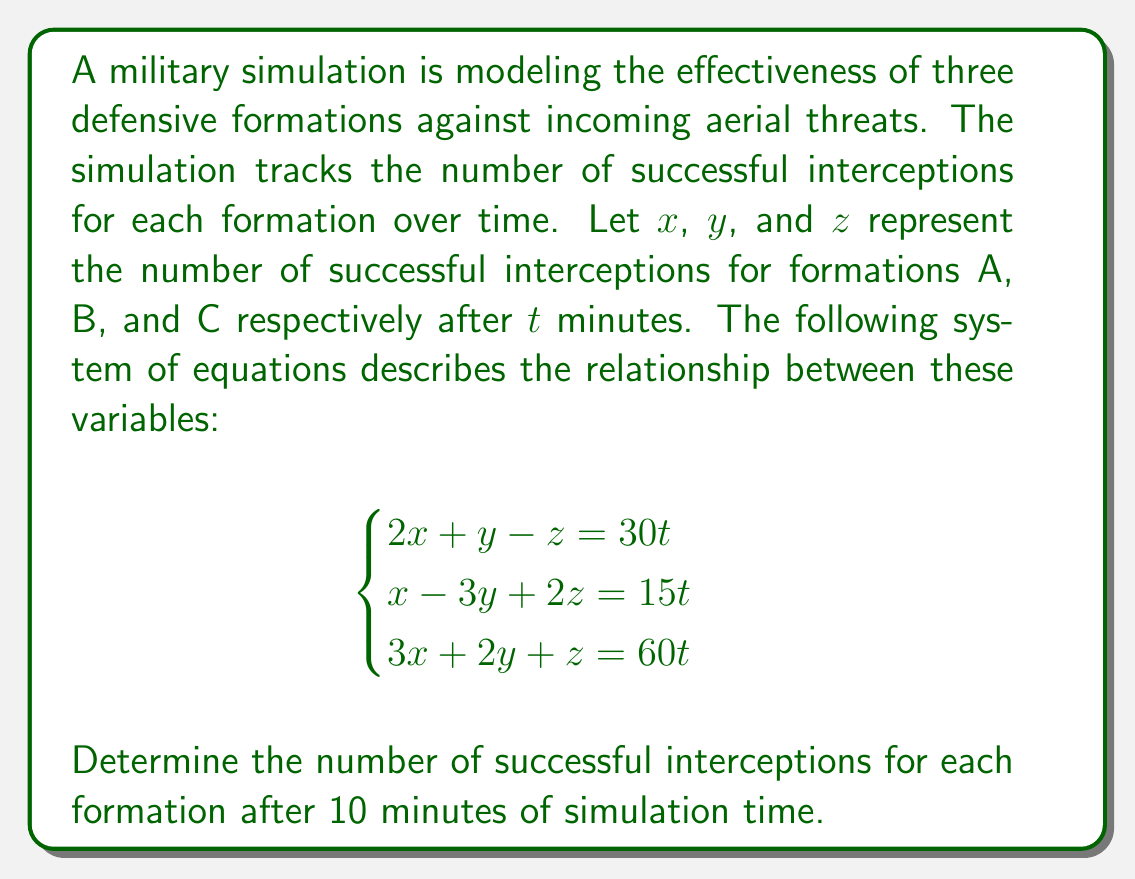Solve this math problem. To solve this system of equations, we'll use the substitution method:

1) From the first equation, express $z$ in terms of $x$ and $y$:
   $z = 2x + y - 30t$

2) Substitute this into the second equation:
   $x - 3y + 2(2x + y - 30t) = 15t$
   $x - 3y + 4x + 2y - 60t = 15t$
   $5x - y = 75t$

3) Substitute the expressions for $z$ and $y$ into the third equation:
   $3x + 2y + (2x + y - 30t) = 60t$
   $3x + 2y + 2x + y - 30t = 60t$
   $5x + 3y = 90t$

4) Now we have two equations with two unknowns:
   $5x - y = 75t$
   $5x + 3y = 90t$

5) Subtract the first equation from the second:
   $4y = 15t$
   $y = \frac{15t}{4}$

6) Substitute this back into $5x - y = 75t$:
   $5x - \frac{15t}{4} = 75t$
   $20x - 15t = 300t$
   $20x = 315t$
   $x = \frac{315t}{20}$

7) Now we can find $z$ using the original equation:
   $z = 2(\frac{315t}{20}) + \frac{15t}{4} - 30t$
   $z = \frac{315t}{10} + \frac{15t}{4} - 30t$
   $z = \frac{126t}{4} + \frac{15t}{4} - \frac{120t}{4}$
   $z = \frac{21t}{4}$

8) For $t = 10$ minutes, we can calculate:
   $x = \frac{315 * 10}{20} = 157.5$
   $y = \frac{15 * 10}{4} = 37.5$
   $z = \frac{21 * 10}{4} = 52.5$
Answer: After 10 minutes of simulation time:
Formation A: 157.5 successful interceptions
Formation B: 37.5 successful interceptions
Formation C: 52.5 successful interceptions 